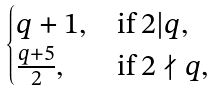<formula> <loc_0><loc_0><loc_500><loc_500>\begin{cases} q + 1 , & \text {if } 2 | q , \\ \frac { q + 5 } { 2 } , & \text {if } 2 \nmid q , \end{cases}</formula> 